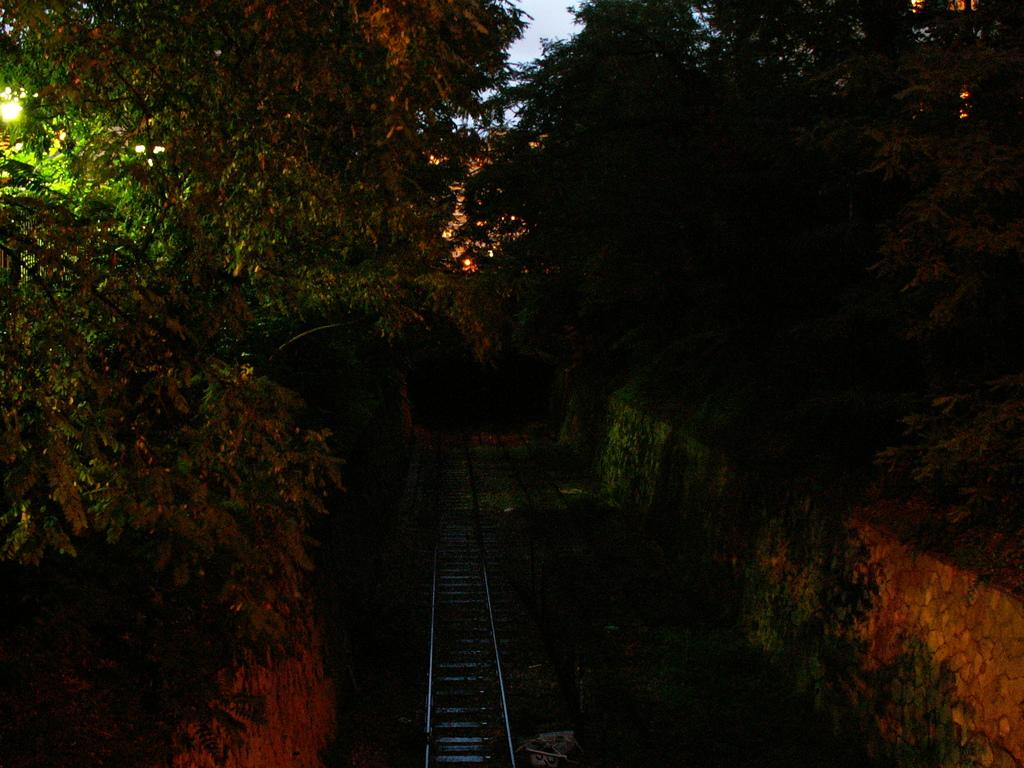What type of natural elements can be seen in the image? There are trees in the image. What type of man-made structures are present in the image? There are walls in the image. What transportation feature is visible at the bottom of the image? There is a railway track at the bottom of the image. What part of the natural environment is visible in the background of the image? The sky is visible in the background of the image. What type of illumination is present in the image? There are lights in the image. What type of toothbrush is being used by the beginner in the image? There is no toothbrush or beginner present in the image. What thought is being expressed by the person in the image? There is no person or thought expressed in the image. 